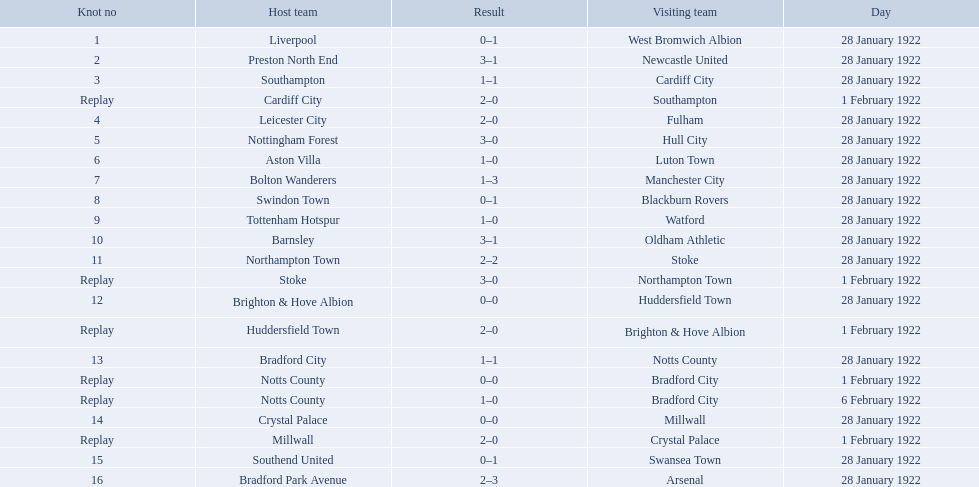Which team had a score of 0-1? Liverpool. Which team had a replay? Cardiff City. Which team had the same score as aston villa? Tottenham Hotspur. What was the score in the aston villa game? 1–0. Which other team had an identical score? Tottenham Hotspur. 